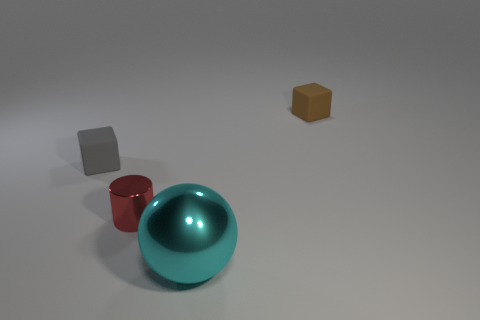Is there anything else of the same color as the big ball?
Your answer should be very brief. No. There is another rubber thing that is the same shape as the tiny brown matte object; what color is it?
Offer a terse response. Gray. Are there more objects that are right of the small brown matte block than small purple matte cubes?
Your answer should be compact. No. What color is the metal thing that is in front of the small red metallic cylinder?
Your answer should be compact. Cyan. Does the brown object have the same size as the gray block?
Make the answer very short. Yes. What size is the red metal cylinder?
Your response must be concise. Small. Is the number of blue cylinders greater than the number of cylinders?
Your response must be concise. No. What color is the matte thing on the left side of the brown matte object behind the small block in front of the brown matte block?
Provide a succinct answer. Gray. There is a matte object behind the tiny gray thing; is it the same shape as the large object?
Your answer should be very brief. No. There is a cylinder that is the same size as the brown object; what is its color?
Ensure brevity in your answer.  Red. 